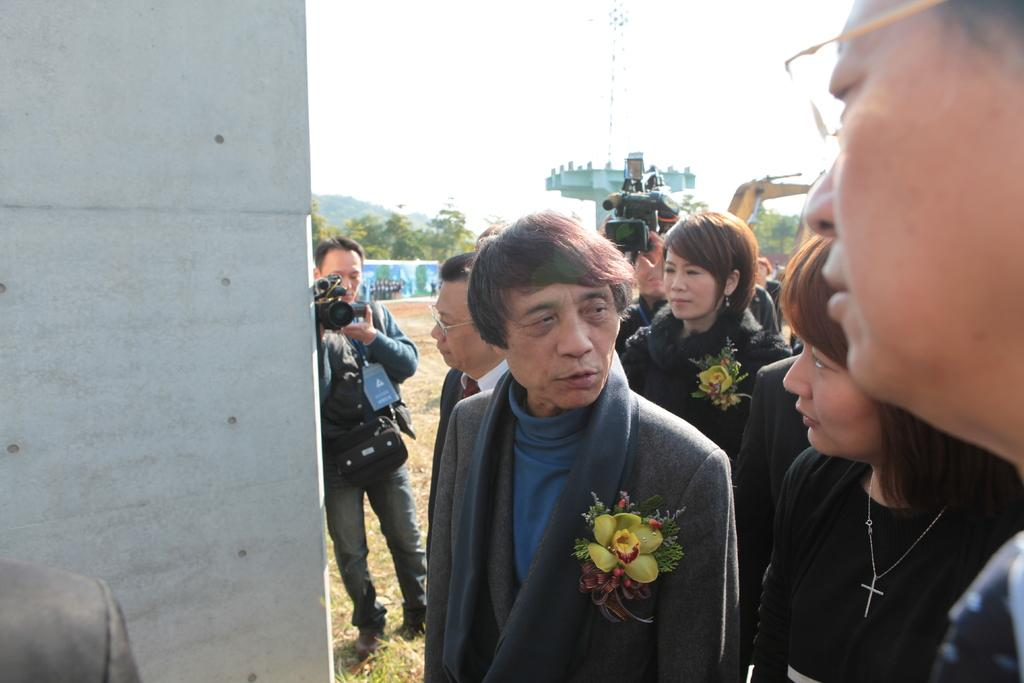How many people are present in the image? There are people in the image, but the exact number is not specified. What are two people doing in the image? Two people are holding cameras in the image. What is located behind the people in the image? There is a wall in the image, and trees and the sky are visible in the background. How many babies are present in the image? There is no mention of babies in the image, so we cannot determine their presence or number. 